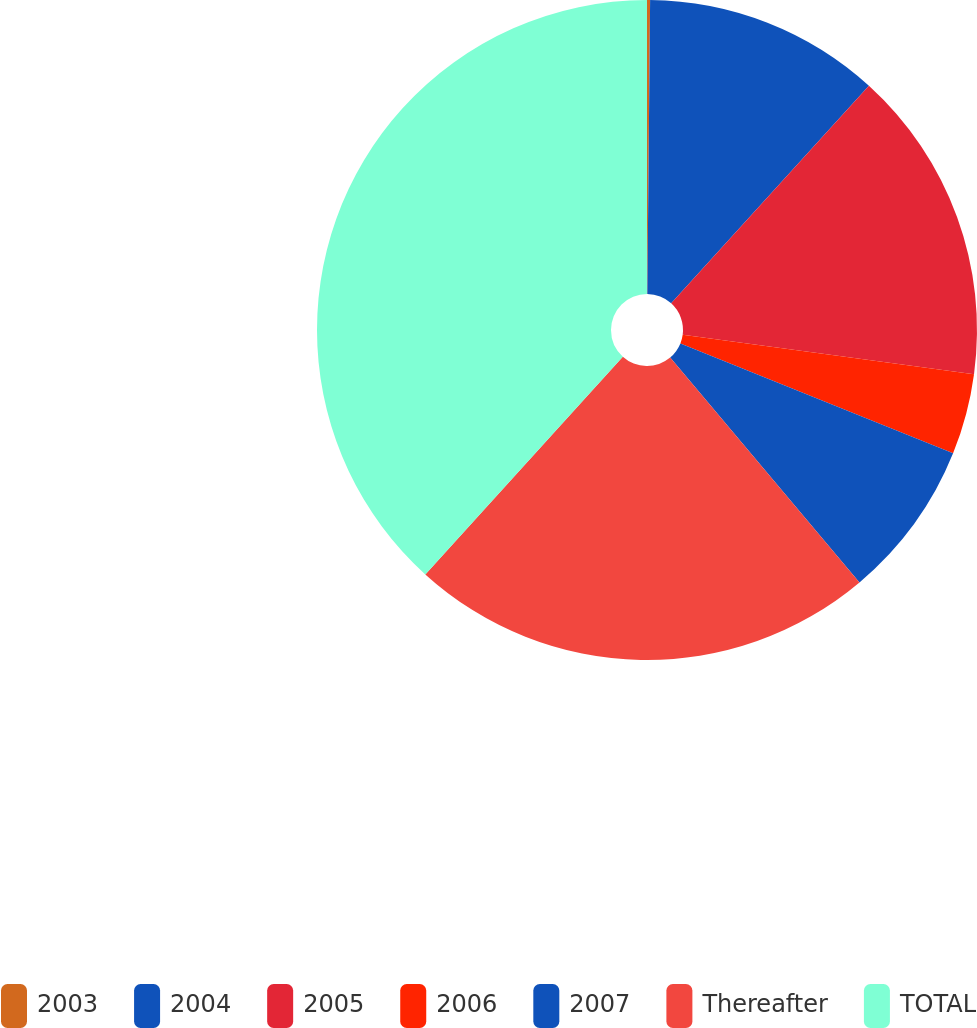<chart> <loc_0><loc_0><loc_500><loc_500><pie_chart><fcel>2003<fcel>2004<fcel>2005<fcel>2006<fcel>2007<fcel>Thereafter<fcel>TOTAL<nl><fcel>0.15%<fcel>11.59%<fcel>15.4%<fcel>3.96%<fcel>7.77%<fcel>22.86%<fcel>38.28%<nl></chart> 